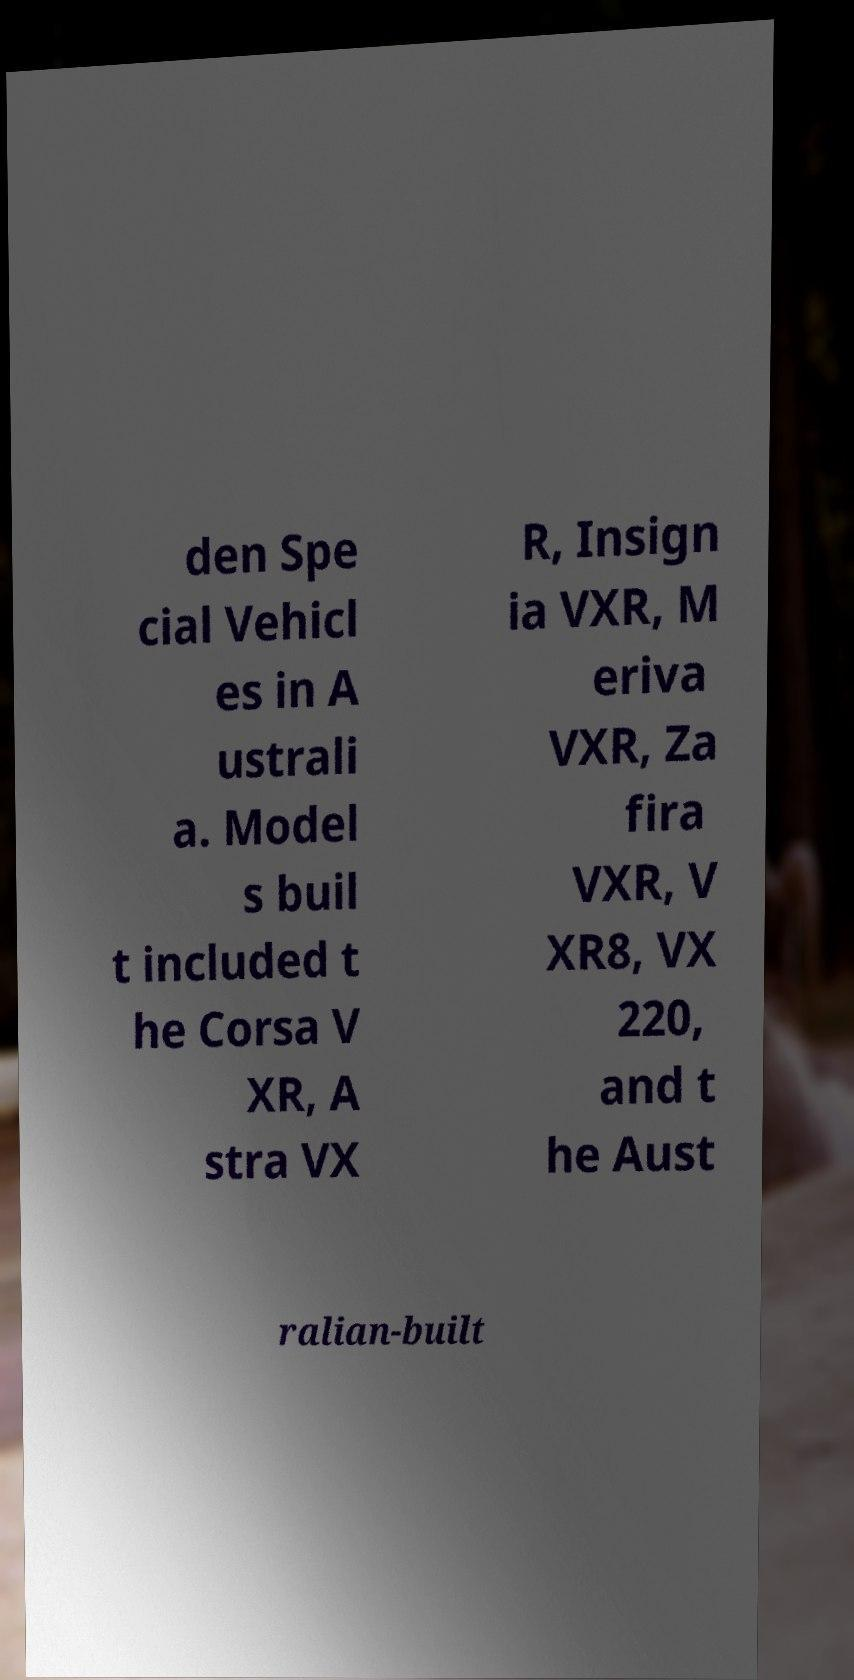What messages or text are displayed in this image? I need them in a readable, typed format. den Spe cial Vehicl es in A ustrali a. Model s buil t included t he Corsa V XR, A stra VX R, Insign ia VXR, M eriva VXR, Za fira VXR, V XR8, VX 220, and t he Aust ralian-built 